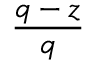Convert formula to latex. <formula><loc_0><loc_0><loc_500><loc_500>\frac { q - z } { q }</formula> 